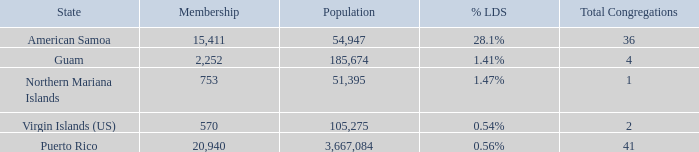What is the highest Population, when State is Puerto Rico, and when Total Congregations is greater than 41? None. 